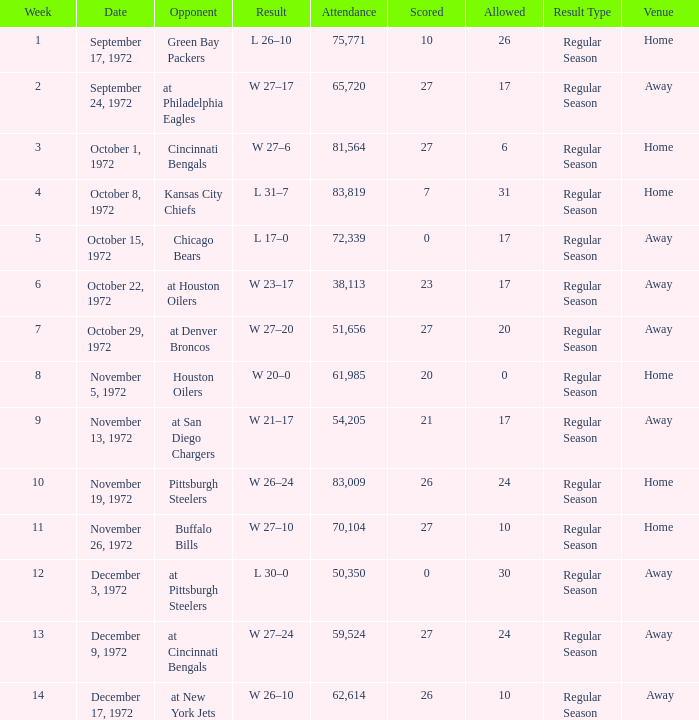What is the sum of week number(s) had an attendance of 61,985? 1.0. Write the full table. {'header': ['Week', 'Date', 'Opponent', 'Result', 'Attendance', 'Scored', 'Allowed', 'Result Type', 'Venue '], 'rows': [['1', 'September 17, 1972', 'Green Bay Packers', 'L 26–10', '75,771', '10', '26', 'Regular Season', 'Home '], ['2', 'September 24, 1972', 'at Philadelphia Eagles', 'W 27–17', '65,720', '27', '17', 'Regular Season', 'Away '], ['3', 'October 1, 1972', 'Cincinnati Bengals', 'W 27–6', '81,564', '27', '6', 'Regular Season', 'Home '], ['4', 'October 8, 1972', 'Kansas City Chiefs', 'L 31–7', '83,819', '7', '31', 'Regular Season', 'Home '], ['5', 'October 15, 1972', 'Chicago Bears', 'L 17–0', '72,339', '0', '17', 'Regular Season', 'Away '], ['6', 'October 22, 1972', 'at Houston Oilers', 'W 23–17', '38,113', '23', '17', 'Regular Season', 'Away '], ['7', 'October 29, 1972', 'at Denver Broncos', 'W 27–20', '51,656', '27', '20', 'Regular Season', 'Away '], ['8', 'November 5, 1972', 'Houston Oilers', 'W 20–0', '61,985', '20', '0', 'Regular Season', 'Home '], ['9', 'November 13, 1972', 'at San Diego Chargers', 'W 21–17', '54,205', '21', '17', 'Regular Season', 'Away '], ['10', 'November 19, 1972', 'Pittsburgh Steelers', 'W 26–24', '83,009', '26', '24', 'Regular Season', 'Home '], ['11', 'November 26, 1972', 'Buffalo Bills', 'W 27–10', '70,104', '27', '10', 'Regular Season', 'Home '], ['12', 'December 3, 1972', 'at Pittsburgh Steelers', 'L 30–0', '50,350', '0', '30', 'Regular Season', 'Away '], ['13', 'December 9, 1972', 'at Cincinnati Bengals', 'W 27–24', '59,524', '27', '24', 'Regular Season', 'Away '], ['14', 'December 17, 1972', 'at New York Jets', 'W 26–10', '62,614', '26', '10', 'Regular Season', 'Away']]} 